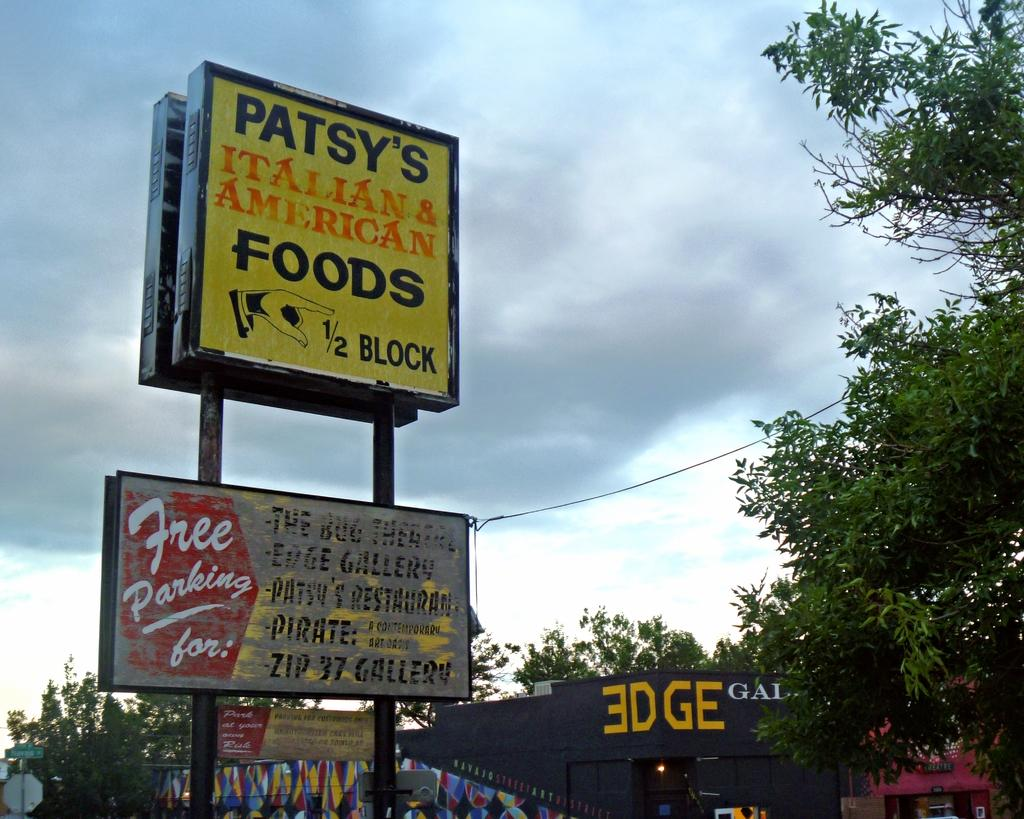<image>
Offer a succinct explanation of the picture presented. Large sign that says "Patsy's Italian & American Foods." 